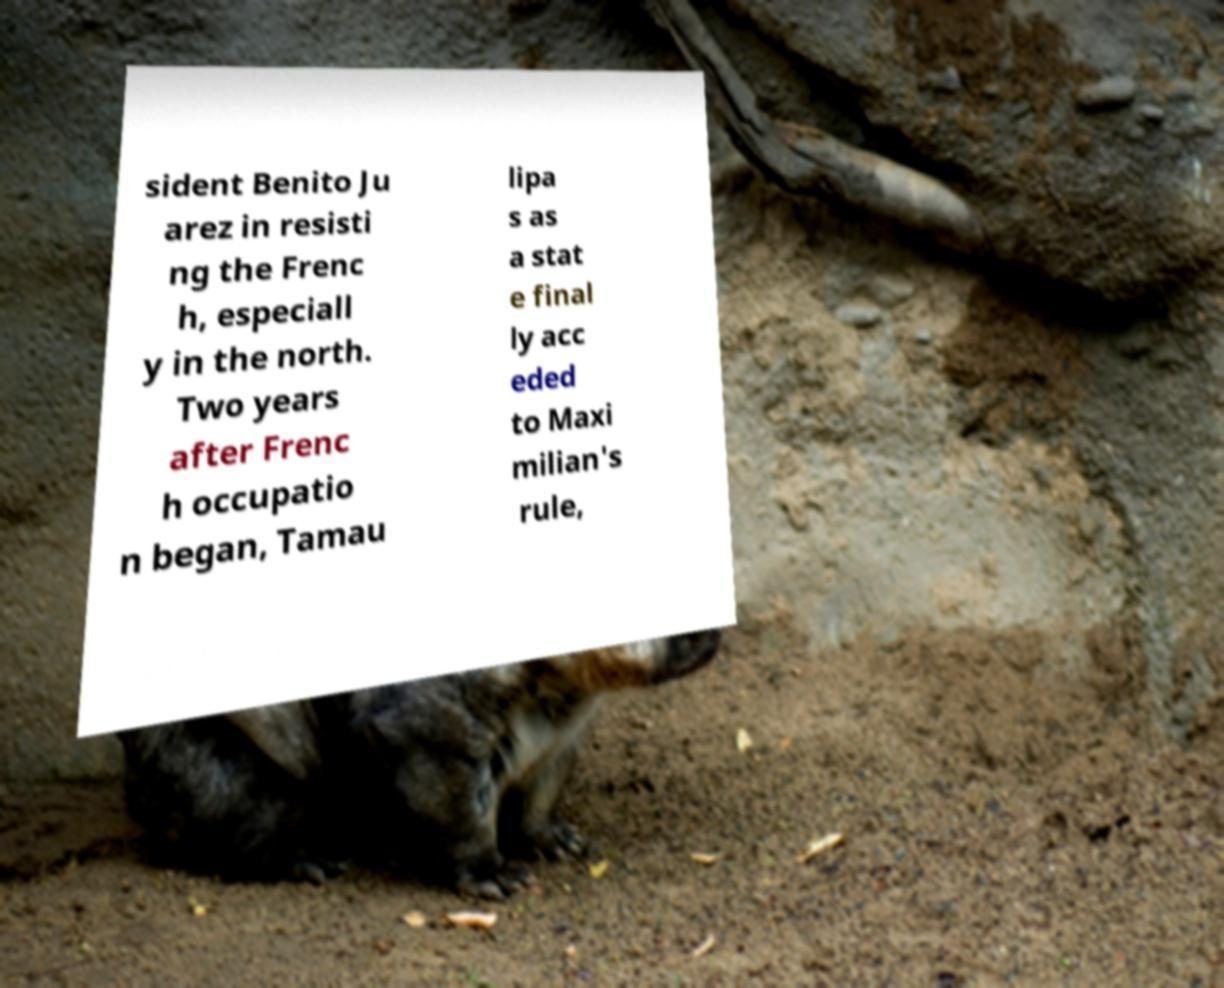Please identify and transcribe the text found in this image. sident Benito Ju arez in resisti ng the Frenc h, especiall y in the north. Two years after Frenc h occupatio n began, Tamau lipa s as a stat e final ly acc eded to Maxi milian's rule, 